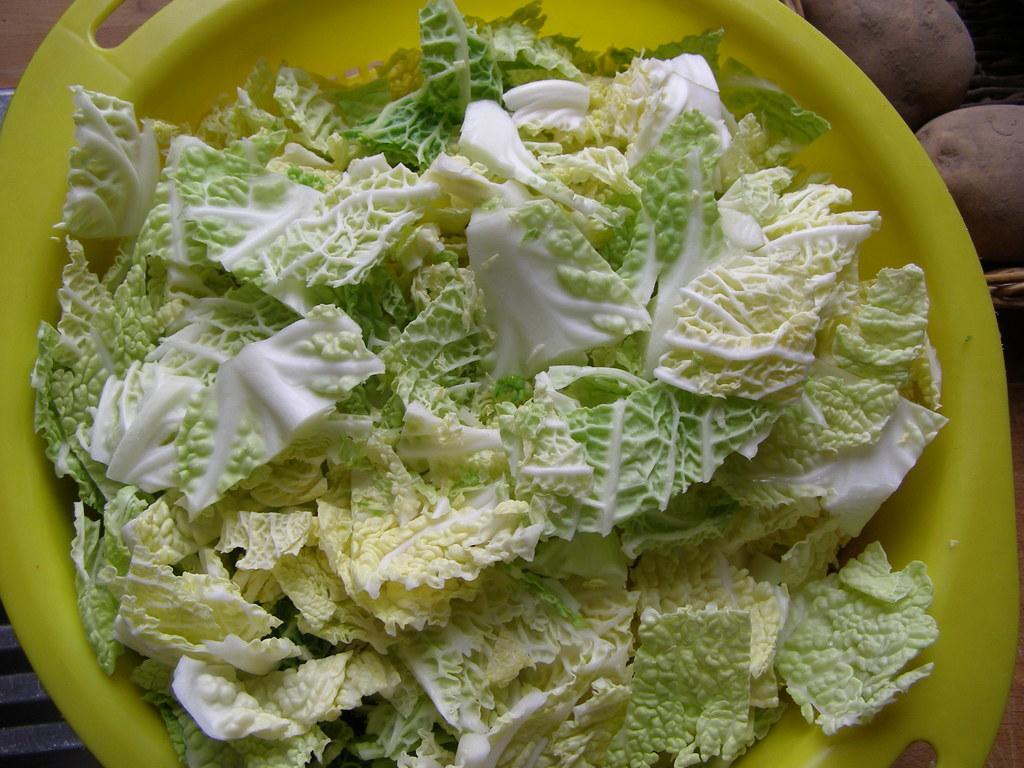How would you summarize this image in a sentence or two? In the center of the image we can see one table. On the table, we can see one cloth, one plate, basket, some vegetables like potatoes, cabbage and a few other objects. 